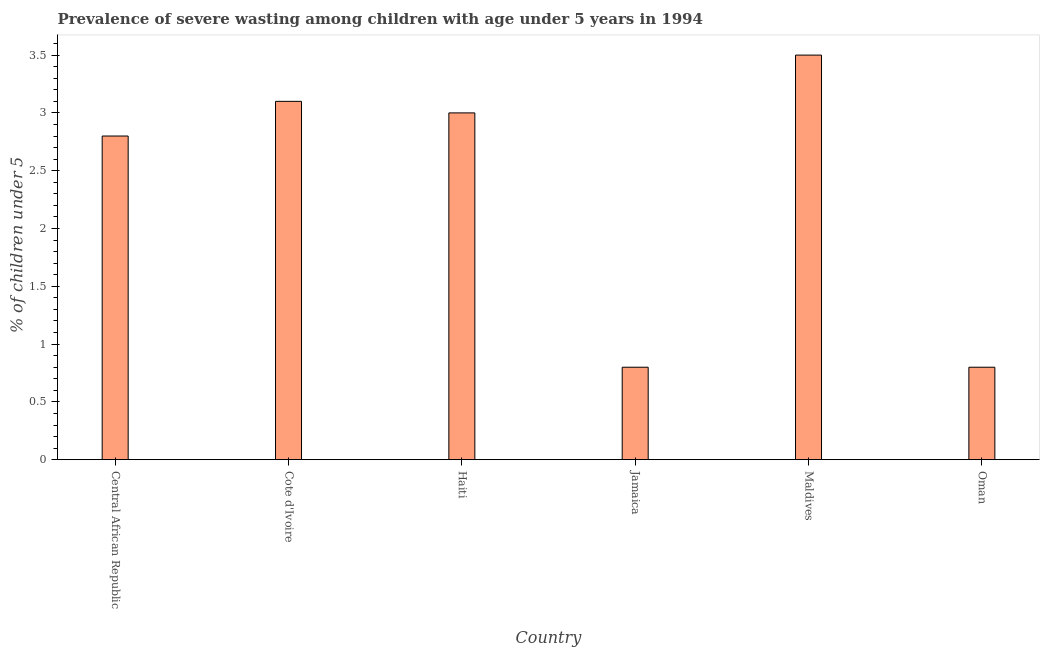Does the graph contain any zero values?
Provide a succinct answer. No. Does the graph contain grids?
Provide a succinct answer. No. What is the title of the graph?
Offer a very short reply. Prevalence of severe wasting among children with age under 5 years in 1994. What is the label or title of the Y-axis?
Your answer should be compact.  % of children under 5. What is the prevalence of severe wasting in Cote d'Ivoire?
Give a very brief answer. 3.1. Across all countries, what is the minimum prevalence of severe wasting?
Provide a succinct answer. 0.8. In which country was the prevalence of severe wasting maximum?
Keep it short and to the point. Maldives. In which country was the prevalence of severe wasting minimum?
Provide a succinct answer. Jamaica. What is the sum of the prevalence of severe wasting?
Your response must be concise. 14. What is the average prevalence of severe wasting per country?
Offer a very short reply. 2.33. What is the median prevalence of severe wasting?
Offer a terse response. 2.9. In how many countries, is the prevalence of severe wasting greater than 3.5 %?
Ensure brevity in your answer.  0. What is the ratio of the prevalence of severe wasting in Cote d'Ivoire to that in Haiti?
Your answer should be compact. 1.03. How many bars are there?
Make the answer very short. 6. What is the difference between two consecutive major ticks on the Y-axis?
Offer a terse response. 0.5. What is the  % of children under 5 of Central African Republic?
Make the answer very short. 2.8. What is the  % of children under 5 in Cote d'Ivoire?
Keep it short and to the point. 3.1. What is the  % of children under 5 of Haiti?
Make the answer very short. 3. What is the  % of children under 5 of Jamaica?
Your response must be concise. 0.8. What is the  % of children under 5 of Maldives?
Offer a terse response. 3.5. What is the  % of children under 5 in Oman?
Make the answer very short. 0.8. What is the difference between the  % of children under 5 in Central African Republic and Maldives?
Your response must be concise. -0.7. What is the difference between the  % of children under 5 in Haiti and Jamaica?
Your answer should be very brief. 2.2. What is the difference between the  % of children under 5 in Haiti and Maldives?
Keep it short and to the point. -0.5. What is the difference between the  % of children under 5 in Jamaica and Maldives?
Offer a very short reply. -2.7. What is the difference between the  % of children under 5 in Jamaica and Oman?
Give a very brief answer. 0. What is the difference between the  % of children under 5 in Maldives and Oman?
Make the answer very short. 2.7. What is the ratio of the  % of children under 5 in Central African Republic to that in Cote d'Ivoire?
Provide a succinct answer. 0.9. What is the ratio of the  % of children under 5 in Central African Republic to that in Haiti?
Provide a short and direct response. 0.93. What is the ratio of the  % of children under 5 in Central African Republic to that in Jamaica?
Your response must be concise. 3.5. What is the ratio of the  % of children under 5 in Central African Republic to that in Maldives?
Keep it short and to the point. 0.8. What is the ratio of the  % of children under 5 in Central African Republic to that in Oman?
Keep it short and to the point. 3.5. What is the ratio of the  % of children under 5 in Cote d'Ivoire to that in Haiti?
Make the answer very short. 1.03. What is the ratio of the  % of children under 5 in Cote d'Ivoire to that in Jamaica?
Offer a terse response. 3.88. What is the ratio of the  % of children under 5 in Cote d'Ivoire to that in Maldives?
Ensure brevity in your answer.  0.89. What is the ratio of the  % of children under 5 in Cote d'Ivoire to that in Oman?
Your answer should be compact. 3.88. What is the ratio of the  % of children under 5 in Haiti to that in Jamaica?
Keep it short and to the point. 3.75. What is the ratio of the  % of children under 5 in Haiti to that in Maldives?
Offer a very short reply. 0.86. What is the ratio of the  % of children under 5 in Haiti to that in Oman?
Your answer should be very brief. 3.75. What is the ratio of the  % of children under 5 in Jamaica to that in Maldives?
Ensure brevity in your answer.  0.23. What is the ratio of the  % of children under 5 in Jamaica to that in Oman?
Your answer should be compact. 1. What is the ratio of the  % of children under 5 in Maldives to that in Oman?
Offer a terse response. 4.38. 